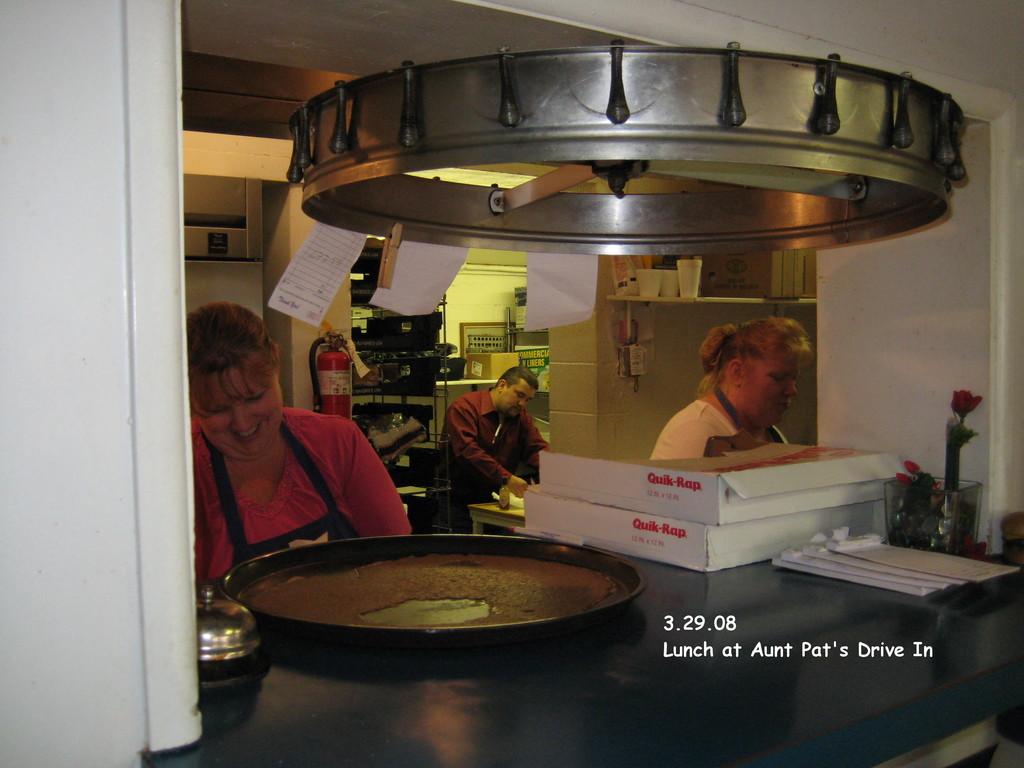What restaurant is this?
Your response must be concise. Aunt pat's drive in. What is the date?
Your response must be concise. 3.29.08. 